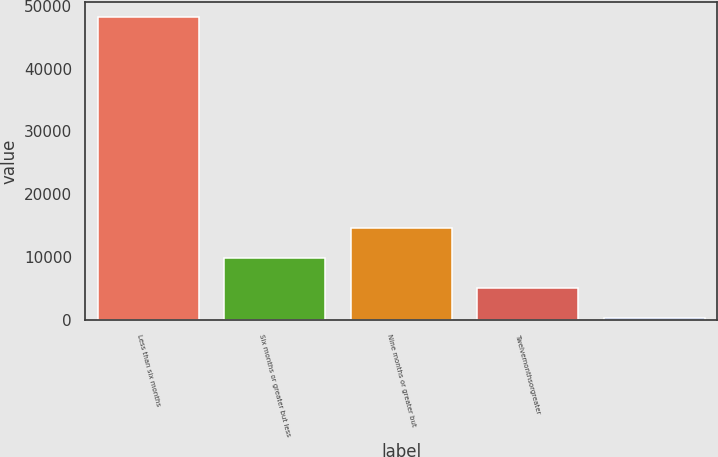<chart> <loc_0><loc_0><loc_500><loc_500><bar_chart><fcel>Less than six months<fcel>Six months or greater but less<fcel>Nine months or greater but<fcel>Twelvemonthsorgreater<fcel>Unnamed: 4<nl><fcel>48114<fcel>9953.2<fcel>14723.3<fcel>5183.1<fcel>413<nl></chart> 